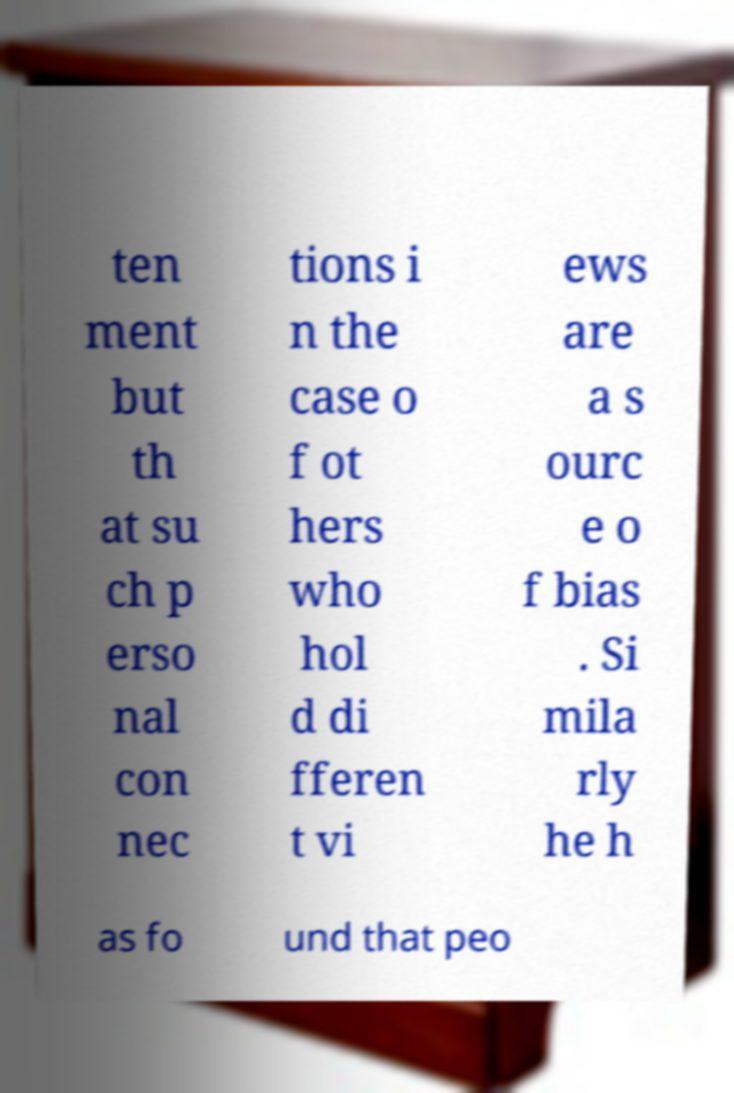Can you read and provide the text displayed in the image?This photo seems to have some interesting text. Can you extract and type it out for me? ten ment but th at su ch p erso nal con nec tions i n the case o f ot hers who hol d di fferen t vi ews are a s ourc e o f bias . Si mila rly he h as fo und that peo 